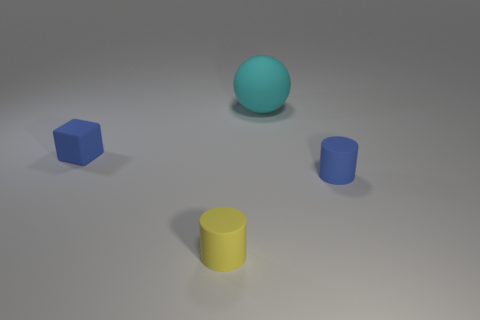Add 1 matte balls. How many objects exist? 5 Subtract 1 blocks. How many blocks are left? 0 Subtract all red cylinders. Subtract all purple blocks. How many cylinders are left? 2 Subtract all yellow balls. How many yellow cylinders are left? 1 Subtract all cylinders. Subtract all tiny blue matte cylinders. How many objects are left? 1 Add 3 cyan objects. How many cyan objects are left? 4 Add 1 rubber balls. How many rubber balls exist? 2 Subtract 0 green cubes. How many objects are left? 4 